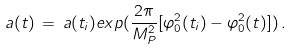Convert formula to latex. <formula><loc_0><loc_0><loc_500><loc_500>a ( t ) \, = \, a ( t _ { i } ) e x p ( { \frac { 2 \pi } { M _ { P } ^ { 2 } } } [ \varphi _ { 0 } ^ { 2 } ( t _ { i } ) - \varphi _ { 0 } ^ { 2 } ( t ) ] ) \, .</formula> 